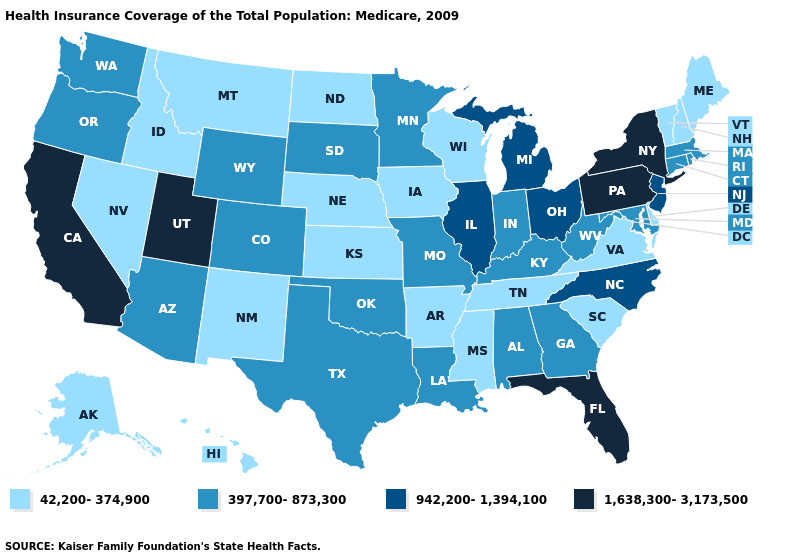Name the states that have a value in the range 942,200-1,394,100?
Be succinct. Illinois, Michigan, New Jersey, North Carolina, Ohio. What is the value of Maryland?
Answer briefly. 397,700-873,300. Does Idaho have the same value as New Hampshire?
Be succinct. Yes. Name the states that have a value in the range 1,638,300-3,173,500?
Short answer required. California, Florida, New York, Pennsylvania, Utah. What is the highest value in the South ?
Keep it brief. 1,638,300-3,173,500. Name the states that have a value in the range 397,700-873,300?
Short answer required. Alabama, Arizona, Colorado, Connecticut, Georgia, Indiana, Kentucky, Louisiana, Maryland, Massachusetts, Minnesota, Missouri, Oklahoma, Oregon, Rhode Island, South Dakota, Texas, Washington, West Virginia, Wyoming. What is the value of Alabama?
Short answer required. 397,700-873,300. Among the states that border Washington , which have the lowest value?
Short answer required. Idaho. Which states have the lowest value in the South?
Concise answer only. Arkansas, Delaware, Mississippi, South Carolina, Tennessee, Virginia. Name the states that have a value in the range 42,200-374,900?
Be succinct. Alaska, Arkansas, Delaware, Hawaii, Idaho, Iowa, Kansas, Maine, Mississippi, Montana, Nebraska, Nevada, New Hampshire, New Mexico, North Dakota, South Carolina, Tennessee, Vermont, Virginia, Wisconsin. What is the value of Michigan?
Short answer required. 942,200-1,394,100. What is the value of Georgia?
Be succinct. 397,700-873,300. Which states have the lowest value in the South?
Keep it brief. Arkansas, Delaware, Mississippi, South Carolina, Tennessee, Virginia. What is the value of Wisconsin?
Concise answer only. 42,200-374,900. How many symbols are there in the legend?
Keep it brief. 4. 